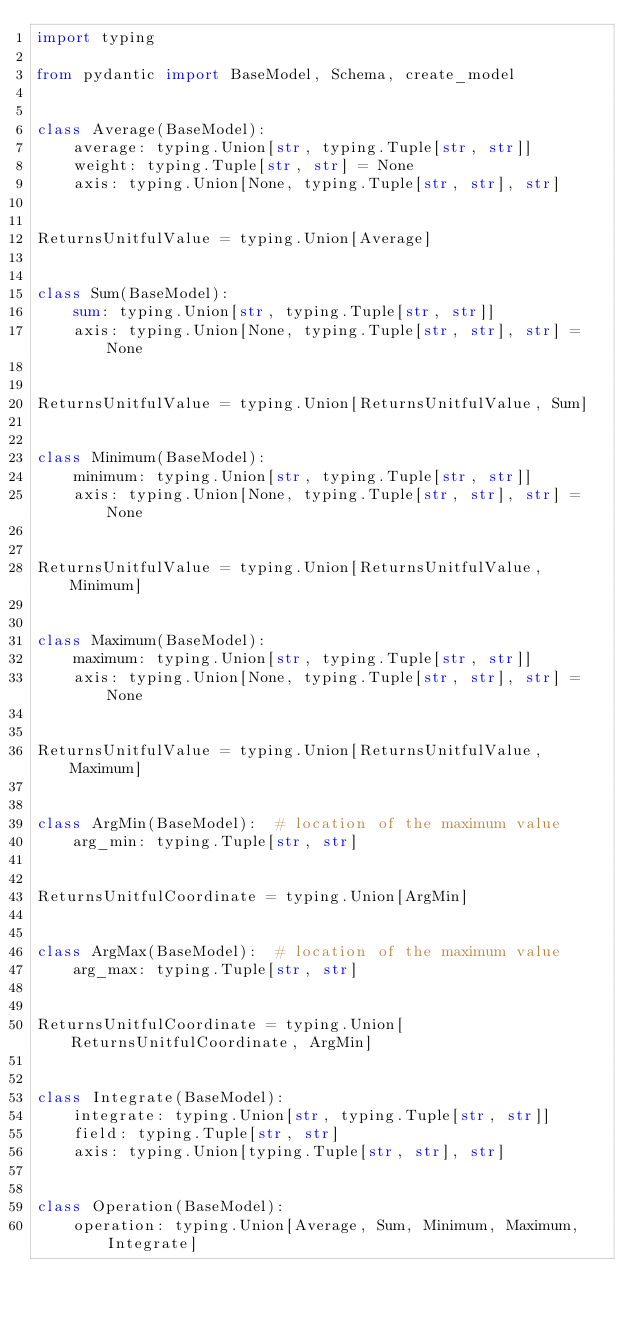Convert code to text. <code><loc_0><loc_0><loc_500><loc_500><_Python_>import typing

from pydantic import BaseModel, Schema, create_model


class Average(BaseModel):
    average: typing.Union[str, typing.Tuple[str, str]]
    weight: typing.Tuple[str, str] = None
    axis: typing.Union[None, typing.Tuple[str, str], str]


ReturnsUnitfulValue = typing.Union[Average]


class Sum(BaseModel):
    sum: typing.Union[str, typing.Tuple[str, str]]
    axis: typing.Union[None, typing.Tuple[str, str], str] = None


ReturnsUnitfulValue = typing.Union[ReturnsUnitfulValue, Sum]


class Minimum(BaseModel):
    minimum: typing.Union[str, typing.Tuple[str, str]]
    axis: typing.Union[None, typing.Tuple[str, str], str] = None


ReturnsUnitfulValue = typing.Union[ReturnsUnitfulValue, Minimum]


class Maximum(BaseModel):
    maximum: typing.Union[str, typing.Tuple[str, str]]
    axis: typing.Union[None, typing.Tuple[str, str], str] = None


ReturnsUnitfulValue = typing.Union[ReturnsUnitfulValue, Maximum]


class ArgMin(BaseModel):  # location of the maximum value
    arg_min: typing.Tuple[str, str]


ReturnsUnitfulCoordinate = typing.Union[ArgMin]


class ArgMax(BaseModel):  # location of the maximum value
    arg_max: typing.Tuple[str, str]


ReturnsUnitfulCoordinate = typing.Union[ReturnsUnitfulCoordinate, ArgMin]


class Integrate(BaseModel):
    integrate: typing.Union[str, typing.Tuple[str, str]]
    field: typing.Tuple[str, str]
    axis: typing.Union[typing.Tuple[str, str], str]


class Operation(BaseModel):
    operation: typing.Union[Average, Sum, Minimum, Maximum, Integrate]
</code> 